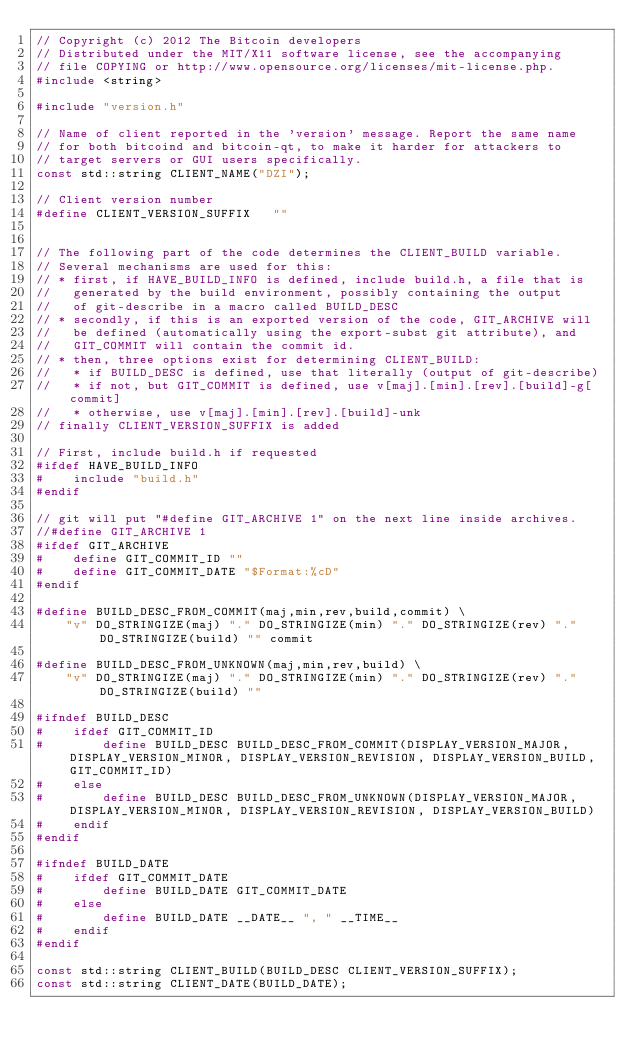<code> <loc_0><loc_0><loc_500><loc_500><_C++_>// Copyright (c) 2012 The Bitcoin developers
// Distributed under the MIT/X11 software license, see the accompanying
// file COPYING or http://www.opensource.org/licenses/mit-license.php.
#include <string>

#include "version.h"

// Name of client reported in the 'version' message. Report the same name
// for both bitcoind and bitcoin-qt, to make it harder for attackers to
// target servers or GUI users specifically.
const std::string CLIENT_NAME("DZI");

// Client version number
#define CLIENT_VERSION_SUFFIX   ""


// The following part of the code determines the CLIENT_BUILD variable.
// Several mechanisms are used for this:
// * first, if HAVE_BUILD_INFO is defined, include build.h, a file that is
//   generated by the build environment, possibly containing the output
//   of git-describe in a macro called BUILD_DESC
// * secondly, if this is an exported version of the code, GIT_ARCHIVE will
//   be defined (automatically using the export-subst git attribute), and
//   GIT_COMMIT will contain the commit id.
// * then, three options exist for determining CLIENT_BUILD:
//   * if BUILD_DESC is defined, use that literally (output of git-describe)
//   * if not, but GIT_COMMIT is defined, use v[maj].[min].[rev].[build]-g[commit]
//   * otherwise, use v[maj].[min].[rev].[build]-unk
// finally CLIENT_VERSION_SUFFIX is added

// First, include build.h if requested
#ifdef HAVE_BUILD_INFO
#    include "build.h"
#endif

// git will put "#define GIT_ARCHIVE 1" on the next line inside archives. 
//#define GIT_ARCHIVE 1
#ifdef GIT_ARCHIVE
#    define GIT_COMMIT_ID ""
#    define GIT_COMMIT_DATE "$Format:%cD"
#endif

#define BUILD_DESC_FROM_COMMIT(maj,min,rev,build,commit) \
    "v" DO_STRINGIZE(maj) "." DO_STRINGIZE(min) "." DO_STRINGIZE(rev) "." DO_STRINGIZE(build) "" commit

#define BUILD_DESC_FROM_UNKNOWN(maj,min,rev,build) \
    "v" DO_STRINGIZE(maj) "." DO_STRINGIZE(min) "." DO_STRINGIZE(rev) "." DO_STRINGIZE(build) ""

#ifndef BUILD_DESC
#    ifdef GIT_COMMIT_ID
#        define BUILD_DESC BUILD_DESC_FROM_COMMIT(DISPLAY_VERSION_MAJOR, DISPLAY_VERSION_MINOR, DISPLAY_VERSION_REVISION, DISPLAY_VERSION_BUILD, GIT_COMMIT_ID)
#    else
#        define BUILD_DESC BUILD_DESC_FROM_UNKNOWN(DISPLAY_VERSION_MAJOR, DISPLAY_VERSION_MINOR, DISPLAY_VERSION_REVISION, DISPLAY_VERSION_BUILD)
#    endif
#endif

#ifndef BUILD_DATE
#    ifdef GIT_COMMIT_DATE
#        define BUILD_DATE GIT_COMMIT_DATE
#    else
#        define BUILD_DATE __DATE__ ", " __TIME__
#    endif
#endif

const std::string CLIENT_BUILD(BUILD_DESC CLIENT_VERSION_SUFFIX);
const std::string CLIENT_DATE(BUILD_DATE);
</code> 